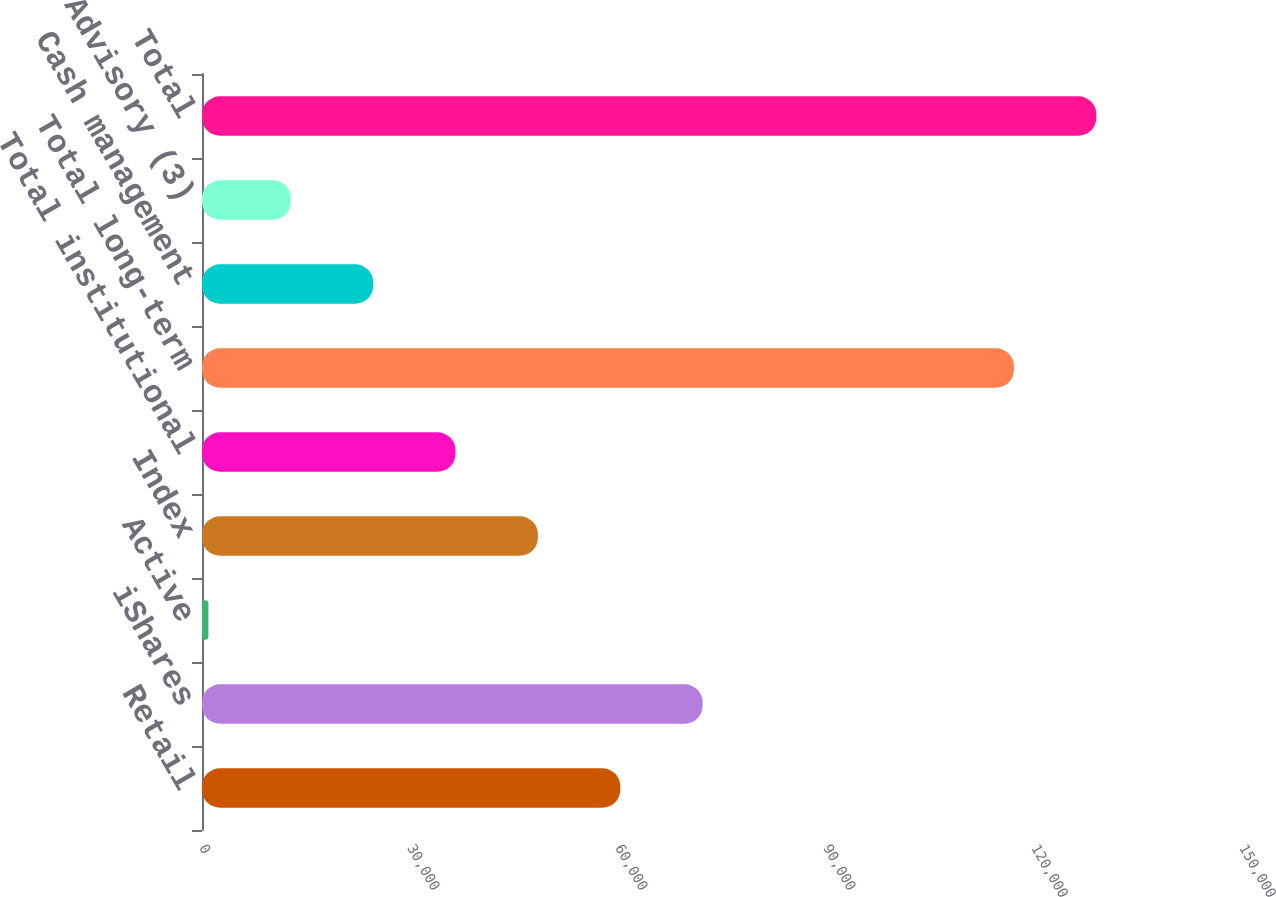Convert chart to OTSL. <chart><loc_0><loc_0><loc_500><loc_500><bar_chart><fcel>Retail<fcel>iShares<fcel>Active<fcel>Index<fcel>Total institutional<fcel>Total long-term<fcel>Cash management<fcel>Advisory (3)<fcel>Total<nl><fcel>60327.5<fcel>72207.4<fcel>928<fcel>48447.6<fcel>36567.7<fcel>117113<fcel>24687.8<fcel>12807.9<fcel>128993<nl></chart> 